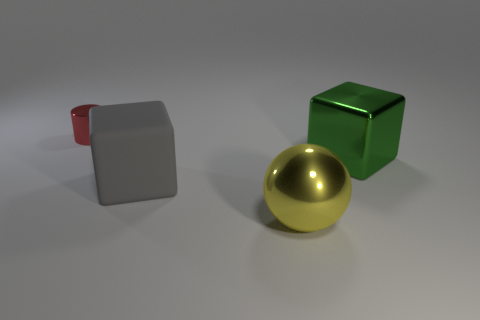Subtract all gray cubes. How many cubes are left? 1 Add 3 tiny metallic cylinders. How many objects exist? 7 Subtract 0 purple spheres. How many objects are left? 4 Subtract all cylinders. How many objects are left? 3 Subtract 1 spheres. How many spheres are left? 0 Subtract all green cylinders. Subtract all red cubes. How many cylinders are left? 1 Subtract all tiny yellow cubes. Subtract all large green metallic cubes. How many objects are left? 3 Add 1 yellow metallic balls. How many yellow metallic balls are left? 2 Add 3 balls. How many balls exist? 4 